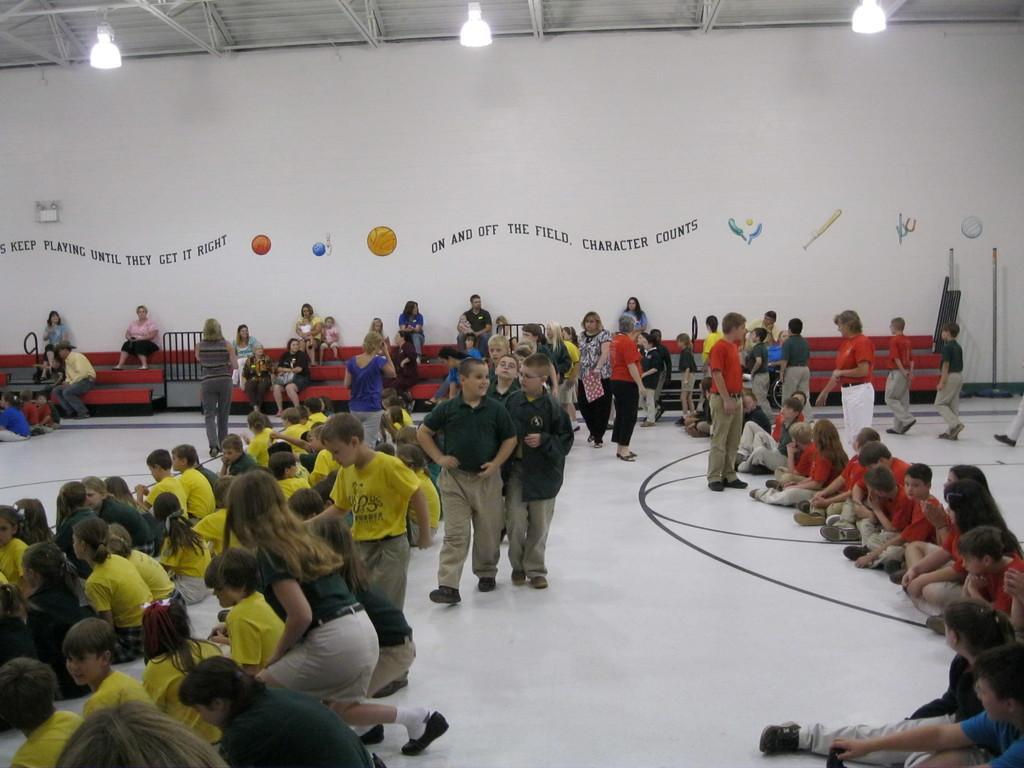Please provide a concise description of this image. In this picture few people seated and few are walking and few are standing and I can see text and few pictures on the wall and few lights to the ceiling. 